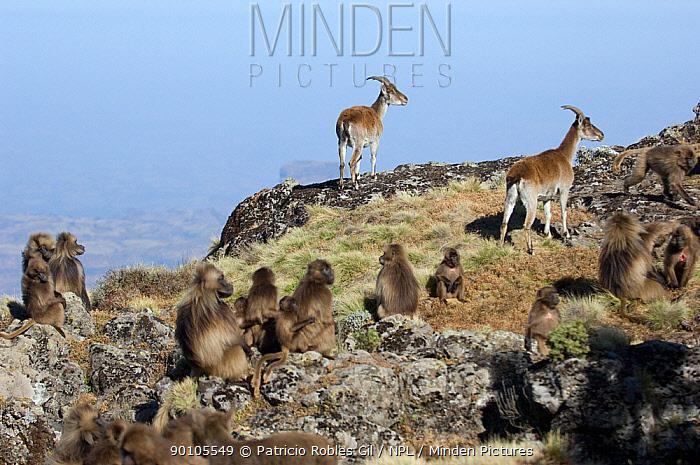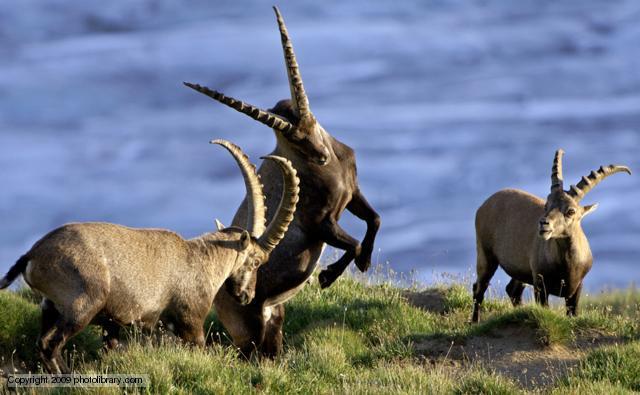The first image is the image on the left, the second image is the image on the right. For the images displayed, is the sentence "An image shows exactly one long-horned animal, which is posed with legs tucked underneath." factually correct? Answer yes or no. No. The first image is the image on the left, the second image is the image on the right. Considering the images on both sides, is "One of the images shows a horned mountain goat laying in the grass with mountains behind it." valid? Answer yes or no. No. 